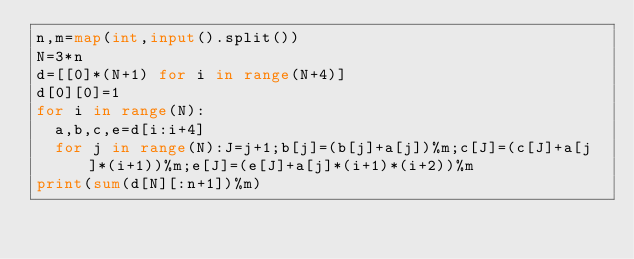Convert code to text. <code><loc_0><loc_0><loc_500><loc_500><_Python_>n,m=map(int,input().split())
N=3*n
d=[[0]*(N+1) for i in range(N+4)]
d[0][0]=1
for i in range(N):
  a,b,c,e=d[i:i+4]
  for j in range(N):J=j+1;b[j]=(b[j]+a[j])%m;c[J]=(c[J]+a[j]*(i+1))%m;e[J]=(e[J]+a[j]*(i+1)*(i+2))%m
print(sum(d[N][:n+1])%m)
</code> 